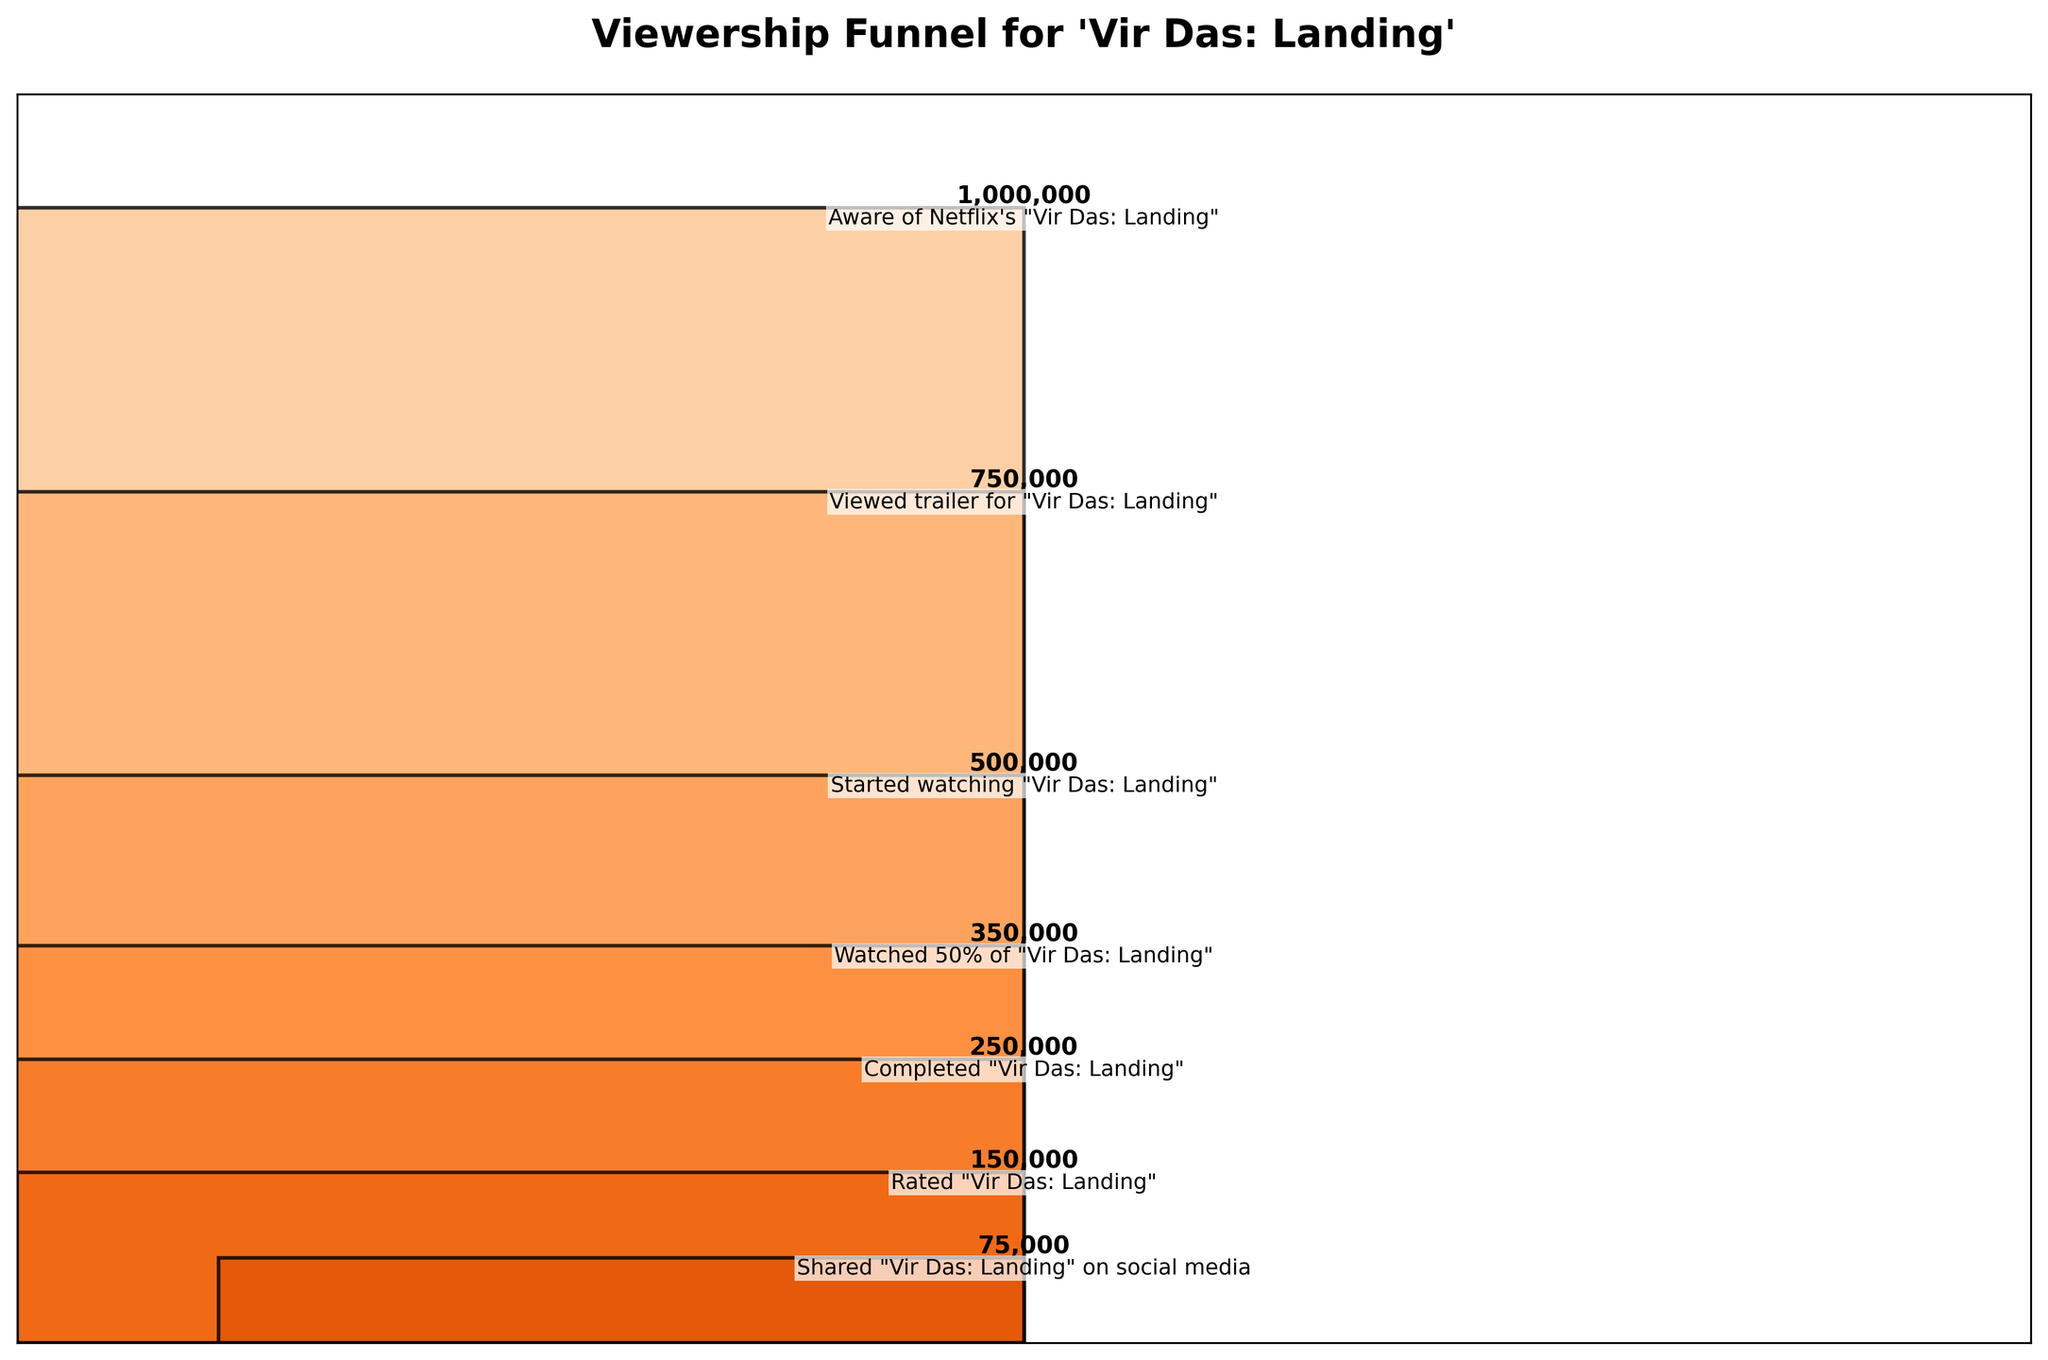What is the title of the figure? The title is located at the top of the figure and summarizes what the plot is about.
Answer: Viewership Funnel for 'Vir Das: Landing' How many stages are shown in the funnel chart? The funnel chart lists the stages vertically from top to bottom. You can count the number of unique stages.
Answer: 7 What is the highest viewership number, and at which stage does it occur? The highest viewership number is the one at the widest part of the funnel, which is at the top.
Answer: 1,000,000 viewers at the "Aware of Netflix's 'Vir Das: Landing'" stage How many viewers completed watching 'Vir Das: Landing'? Look for the stage labelled "Completed 'Vir Das: Landing'" and note the viewership number next to it.
Answer: 250,000 What is the difference in viewership between those who started watching and those who completed it? Subtract the viewership number of the "Completed" stage from that of the "Started watching" stage.
Answer: 500,000 - 250,000 = 250,000 What percentage of viewers who started watching 'Vir Das: Landing' ended up completing it? Divide the number of viewers who completed it by the number of viewers who started watching it, then multiply by 100 to get the percentage.
Answer: (250,000 / 500,000) * 100 = 50% Which stage experienced the largest drop in viewership? Calculate the difference in viewership between consecutive stages and identify the stage with the largest decrease.
Answer: Started watching to Watched 50% (500,000 - 350,000 = 150,000) How many viewers interacted with 'Vir Das: Landing' on social media? Locate the stage "Shared 'Vir Das: Landing' on social media" and note the number of viewers.
Answer: 75,000 What is the ratio of viewers who rated 'Vir Das: Landing' to those who completed it? Divide the number of viewers who rated it by those who completed it.
Answer: 150,000 / 250,000 = 0.6 What proportion of viewers who were aware of 'Vir Das: Landing' actually started watching it? Divide the number of viewers who started watching by the number of viewers who were aware.
Answer: 500,000 / 1,000,000 = 0.5 